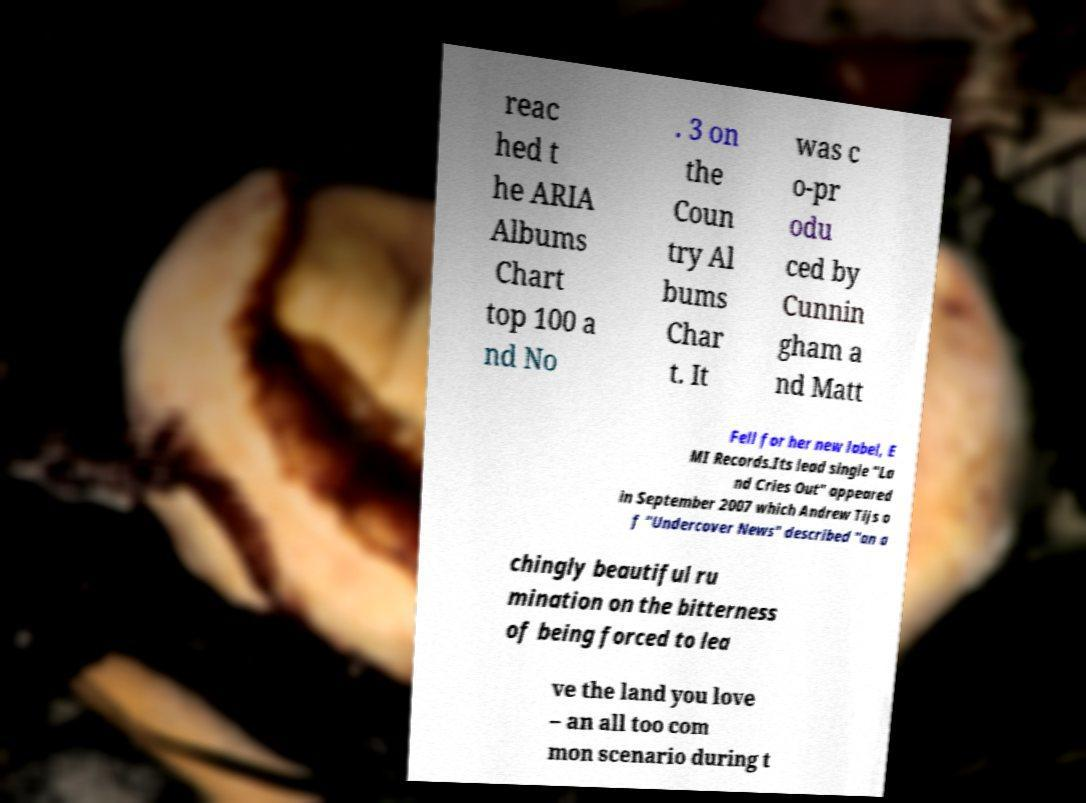There's text embedded in this image that I need extracted. Can you transcribe it verbatim? reac hed t he ARIA Albums Chart top 100 a nd No . 3 on the Coun try Al bums Char t. It was c o-pr odu ced by Cunnin gham a nd Matt Fell for her new label, E MI Records.Its lead single "La nd Cries Out" appeared in September 2007 which Andrew Tijs o f "Undercover News" described "an a chingly beautiful ru mination on the bitterness of being forced to lea ve the land you love – an all too com mon scenario during t 